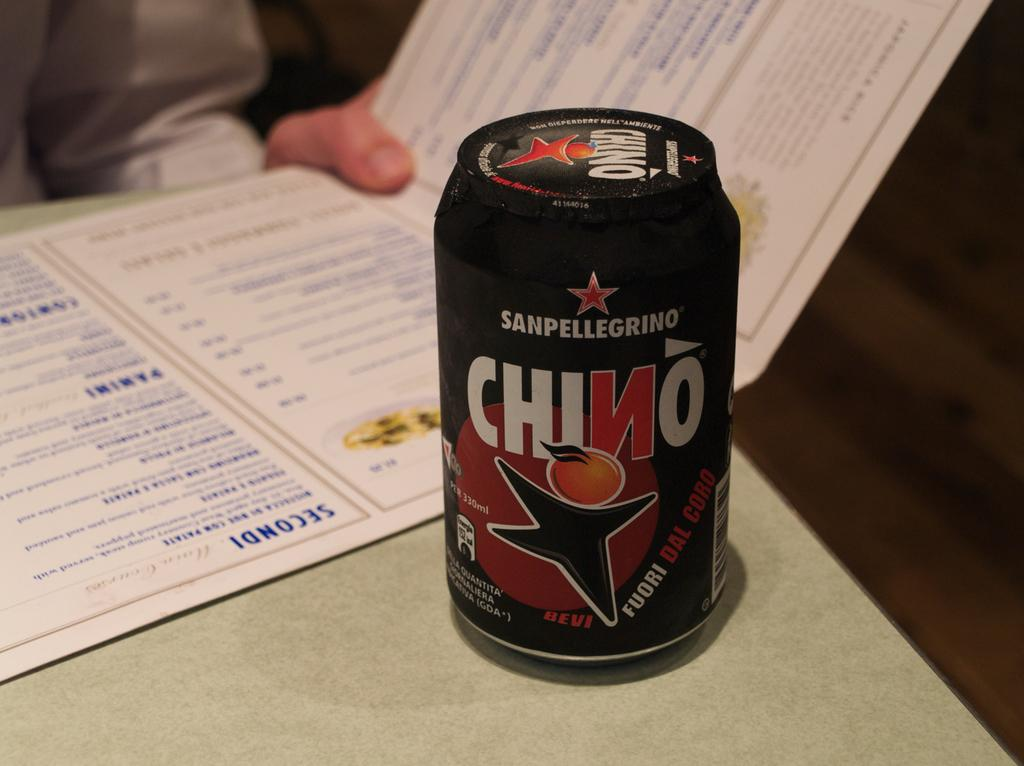Provide a one-sentence caption for the provided image. The can of SanPelligrino has not yet been opened. 